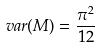Convert formula to latex. <formula><loc_0><loc_0><loc_500><loc_500>v a r ( M ) = \frac { \pi ^ { 2 } } { 1 2 }</formula> 